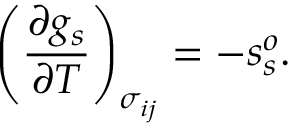<formula> <loc_0><loc_0><loc_500><loc_500>\left ( \frac { \partial g _ { s } } { \partial T } \right ) _ { \sigma _ { i j } } = - s _ { s } ^ { o } .</formula> 